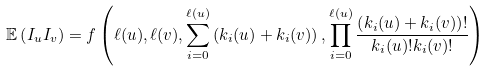Convert formula to latex. <formula><loc_0><loc_0><loc_500><loc_500>\mathbb { E } \left ( I _ { u } I _ { v } \right ) = f \left ( \ell ( u ) , \ell ( v ) , \sum _ { i = 0 } ^ { \ell ( u ) } \left ( k _ { i } ( u ) + k _ { i } ( v ) \right ) , \prod _ { i = 0 } ^ { \ell ( u ) } \frac { \left ( k _ { i } ( u ) + k _ { i } ( v ) \right ) ! } { k _ { i } ( u ) ! k _ { i } ( v ) ! } \right )</formula> 